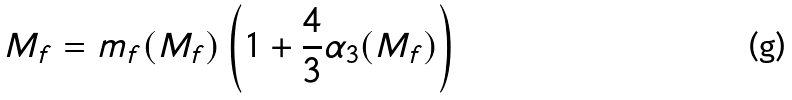Convert formula to latex. <formula><loc_0><loc_0><loc_500><loc_500>M _ { f } = m _ { f } ( M _ { f } ) \left ( 1 + \frac { 4 } { 3 } \alpha _ { 3 } ( M _ { f } ) \right )</formula> 